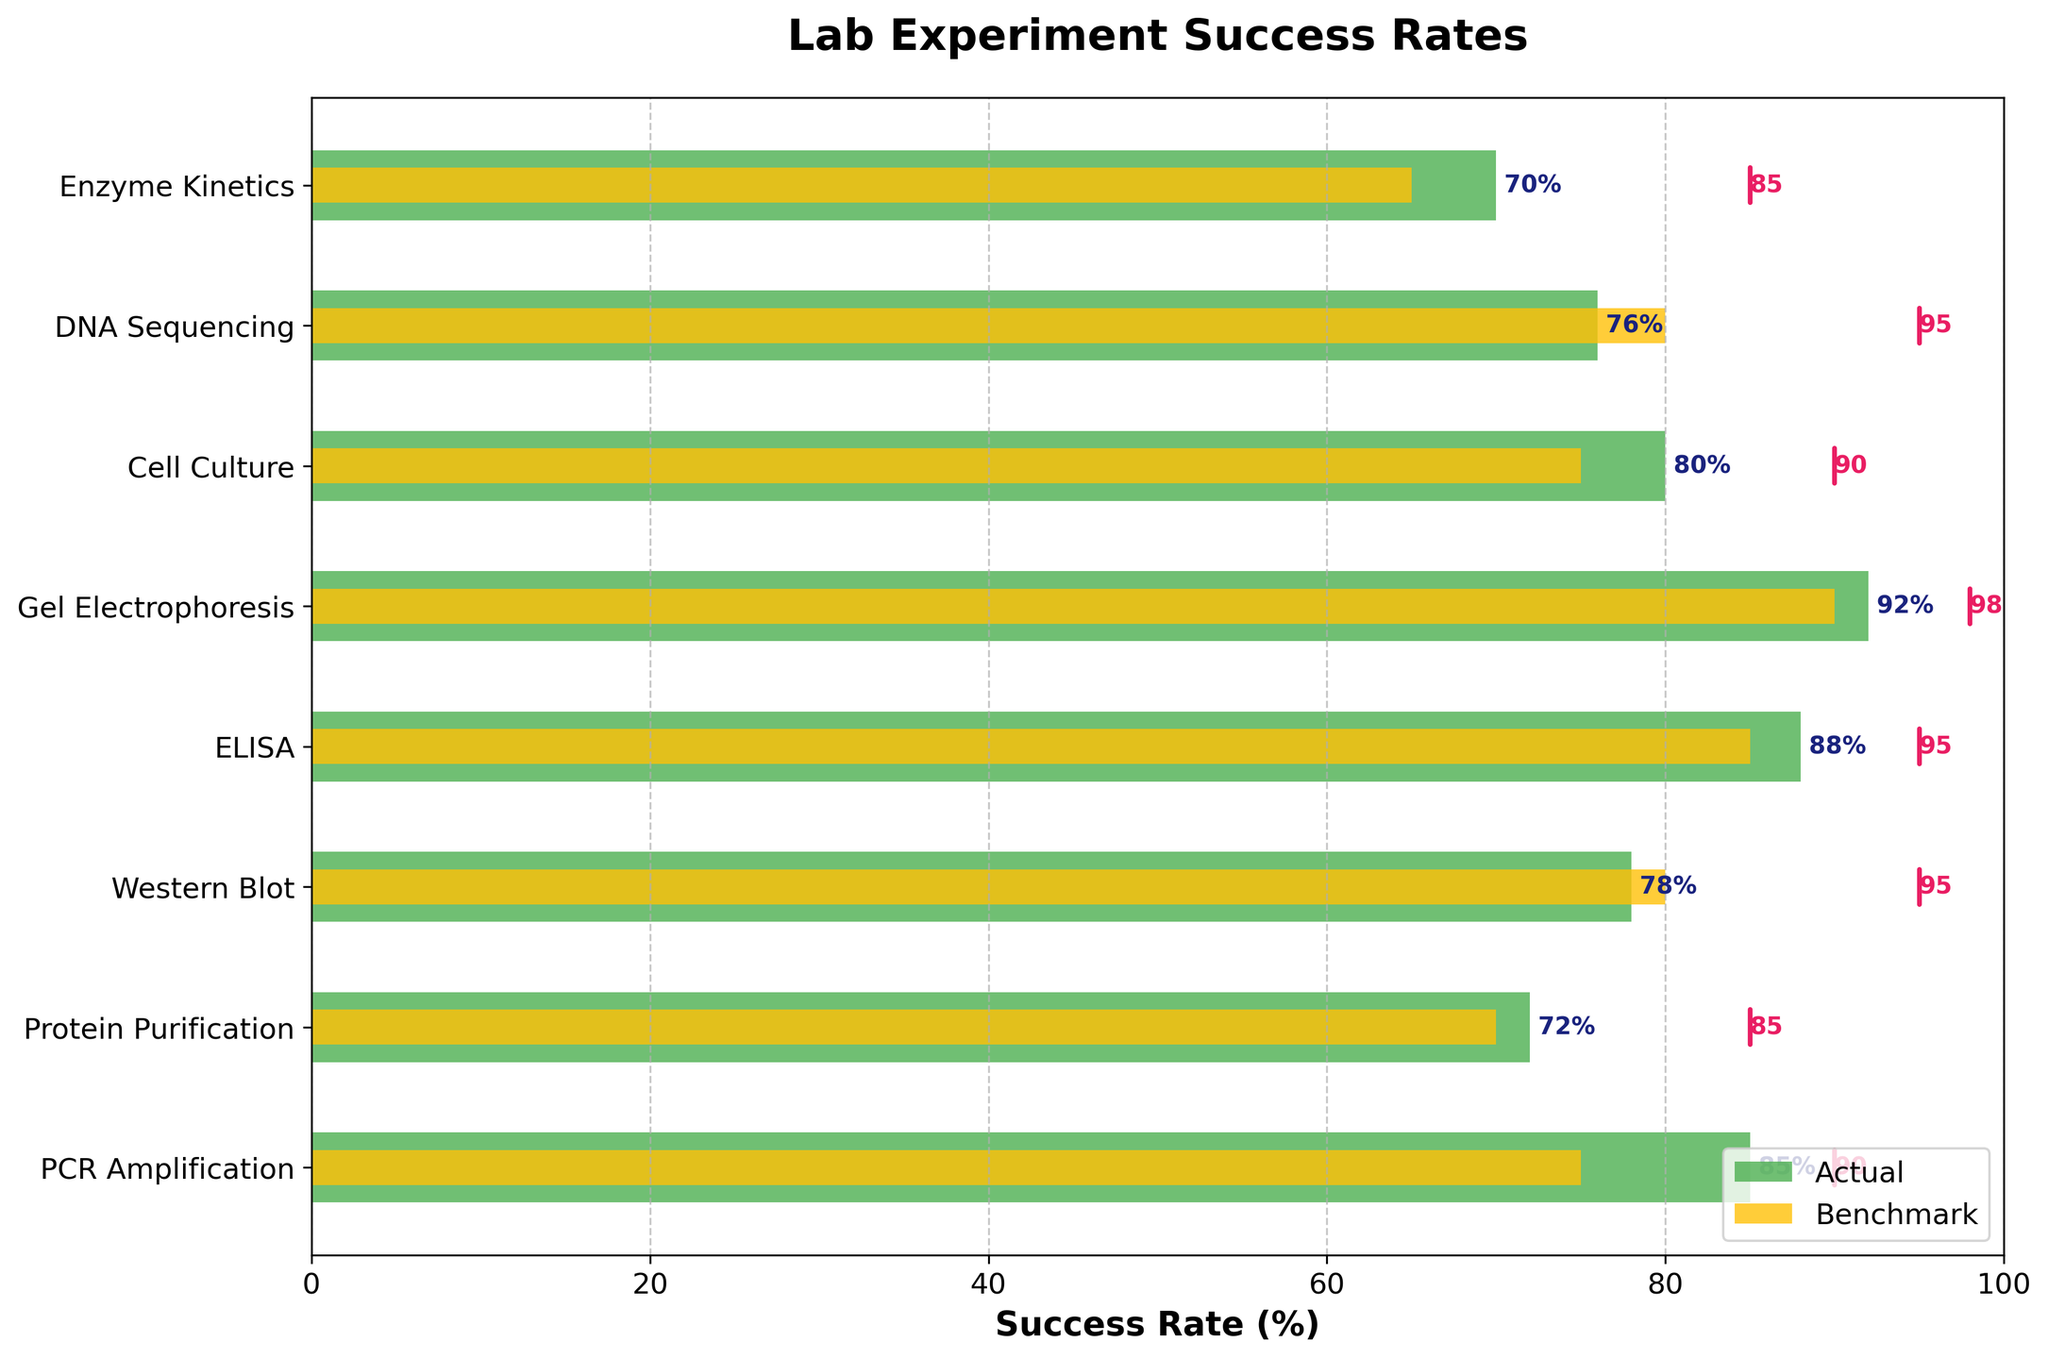Which experiment has the highest actual success rate? The highest actual success rate is the tallest green bar on the plot. The tallest green bar corresponds to "Gel Electrophoresis" with a success rate of 92%.
Answer: Gel Electrophoresis What is the benchmark success rate for PCR Amplification? The benchmark success rate is shown as a short yellow bar for each experiment. For "PCR Amplification," the yellow bar indicates a benchmark of 75%.
Answer: 75% How many experiments have an actual success rate above their benchmark? To find this, compare each green bar (actual success rate) with its corresponding yellow bar (benchmark). Six out of eight experiments have an actual success rate above their benchmark.
Answer: Six Which experiment has the smallest gap between its actual success rate and target? Calculate the difference between the actual success rate (green bar) and the target (pink line) for each experiment. "Gel Electrophoresis" has the smallest gap, with an actual success rate of 92% and a target of 98%, a difference of 6%.
Answer: Gel Electrophoresis For which experiment is the difference between the actual success rate and the target value the largest? Calculate the difference between the actual success rate (green bar) and the target (pink line). For "Western Blot," the success rate is 78%, and the target is 95%, a difference of 17%.
Answer: Western Blot Are there any experiments where the actual success rate meets or exceeds the target value? Check if any green bars reach or surpass their corresponding pink lines. No actual success rates meet or exceed the targets.
Answer: No What is the average actual success rate across all experiments? Sum all actual success rates and divide by the number of experiments: (85 + 72 + 78 + 88 + 92 + 80 + 76 + 70) / 8 = 641 / 8 = 80.125%.
Answer: 80.125% Which experiment has an actual success rate closest to its benchmark? Compare the green bars (actual success rate) and yellow bars (benchmark) and find the smallest difference. "Cell Culture" has an actual success rate of 80% and a benchmark of 75%, a difference of 5%.
Answer: Cell Culture Which experiments have a target success rate of 95%? Look at the labels next to the pink lines to identify the experiments. "Western Blot," "ELISA," and "DNA Sequencing" all have a target success rate of 95%.
Answer: Western Blot, ELISA, DNA Sequencing What's the difference between the actual success rate and benchmark for Enzyme Kinetics? Subtract the benchmark value from the actual success rate: 70% (actual) - 65% (benchmark) = 5%.
Answer: 5% 